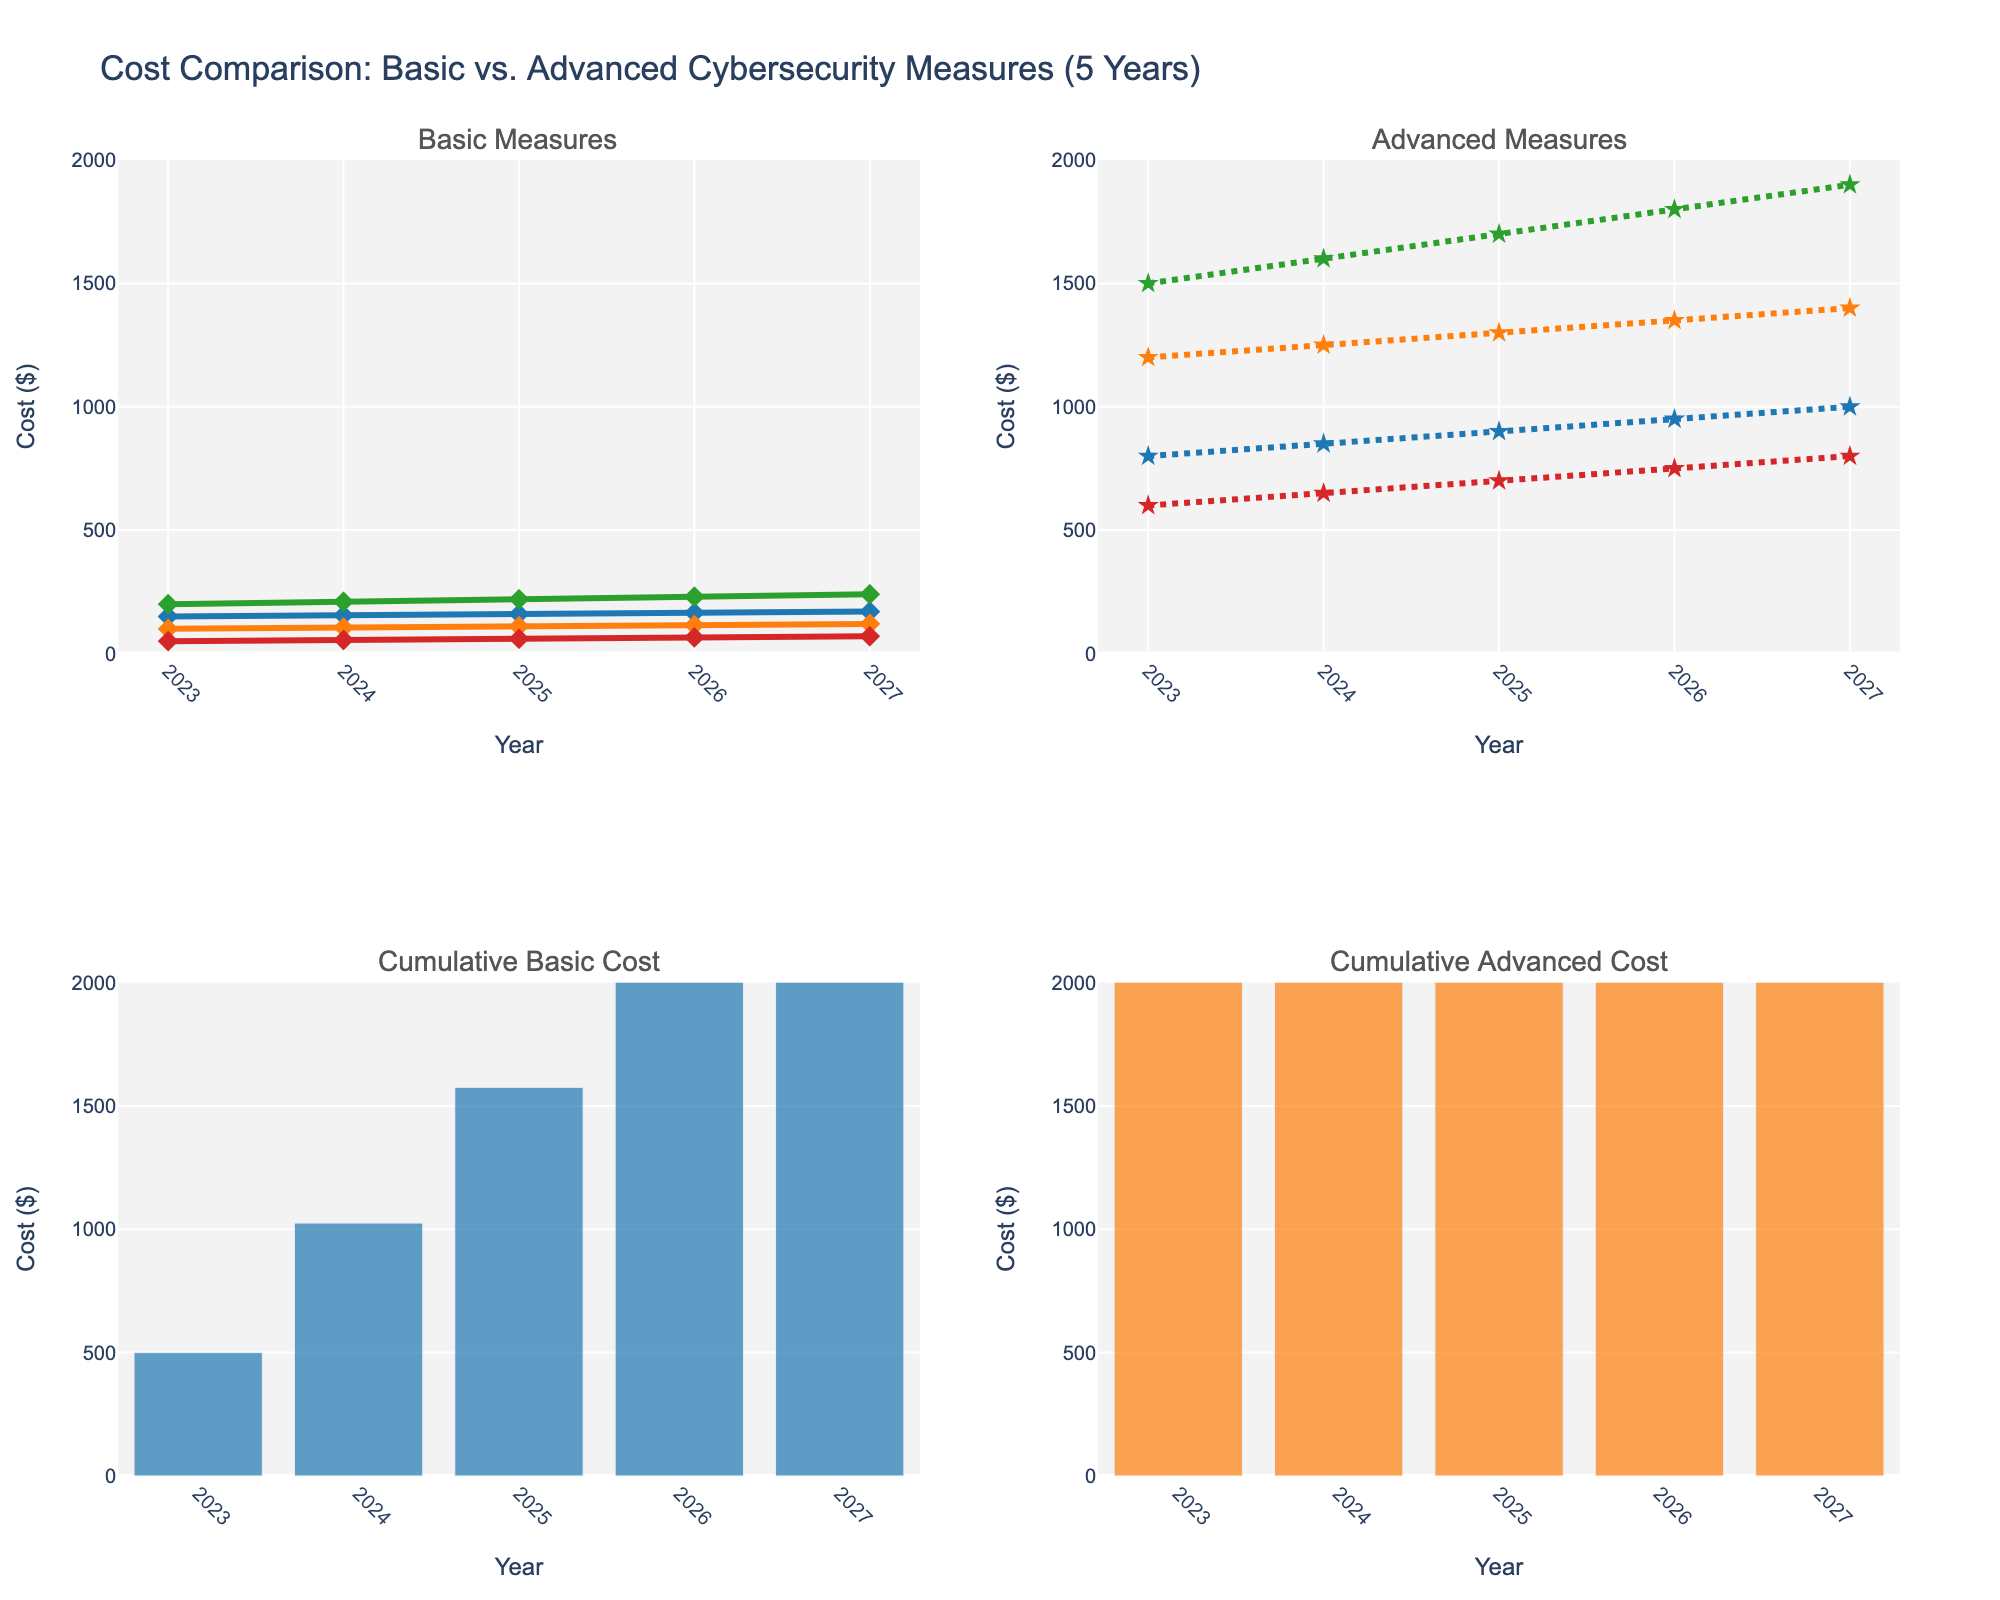What is the main title of the figure? The main title is displayed at the top of the figure. It reads "Cost Comparison: Basic vs. Advanced Cybersecurity Measures (5 Years)"
Answer: Cost Comparison: Basic vs. Advanced Cybersecurity Measures (5 Years) What colors are used to represent the basic measures in the first subplot? The colors used are '#1f77b4', '#ff7f0e', '#2ca02c', and '#d62728' on the lines representing the basic measures. These colors are blue, orange, green, and red respectively.
Answer: Blue, Orange, Green, Red What was the cost of Advanced Endpoint Protection in 2026? To find this, look at the second subplot (advanced measures) and locate the point for 2026 on the Advanced Endpoint Protection line (dashed line). The cost is shown as $950.
Answer: $950 What is the cumulative cost of advanced measures by 2025? To obtain this, examine the third subplot where cumulative costs are shown. Look for the bar representing 2025. The height of this bar indicates the cumulative cost, which is about $9,450.
Answer: About $9,450 How do the cumulative costs of basic and advanced measures compare in 2027? Compare the heights of the bars for 2027 in the third and fourth subplots. The height of the basic measures bar is about $4,215, while the advanced measures bar is about $17,550. The advanced measures have a much higher cumulative cost.
Answer: Advanced measures have a higher cumulative cost Which basic measure saw the smallest increase in cost from 2023 to 2027? Compare the vertical differences in line heights between 2023 and 2027 for each basic measure in the first subplot. The Password Manager line has the smallest increase, going from $50 in 2023 to $70 in 2027.
Answer: Password Manager On the Basic Measures subplot, which measure has a consistently increasing trend from 2023 to 2027? All visualized basic measures show a consistent increase, but the sharpest upwards trend is seen in the Regular Backups' line.
Answer: Regular Backups By how much did the cost of the Next-Gen Firewall increase between 2024 and 2025? Observe the Next-Gen Firewall line (dotted) in the advanced measures subplot. The cost in 2024 is $1250 and in 2025 it is $1300. The increase is $1300 - $1250 = $50.
Answer: $50 